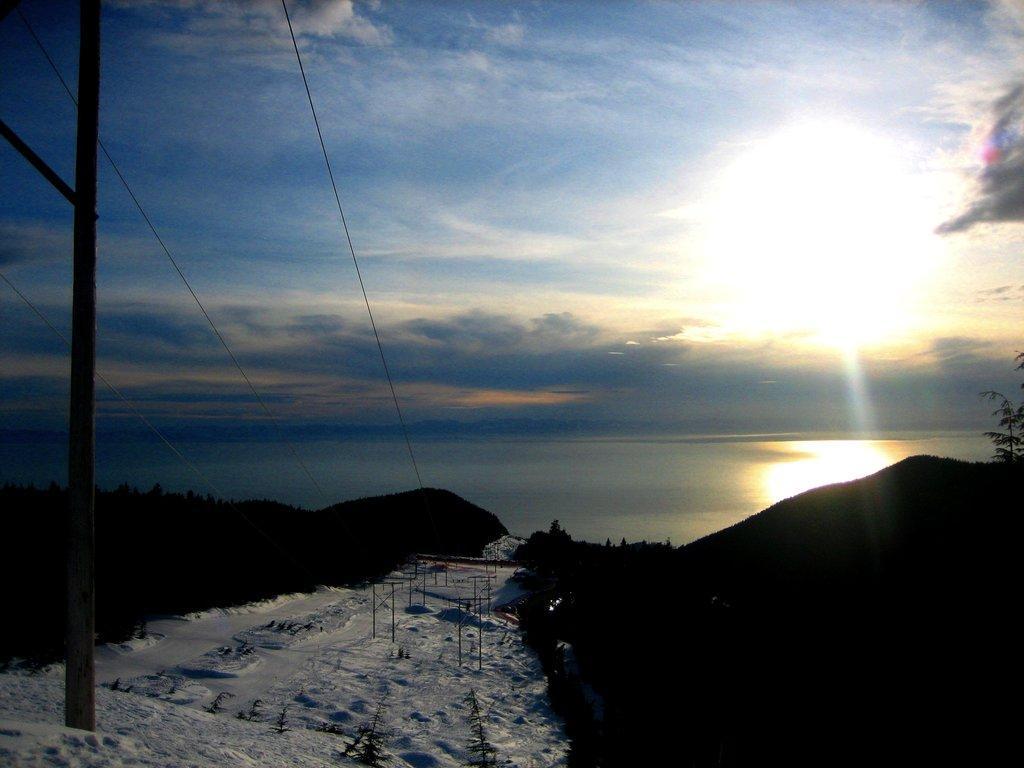In one or two sentences, can you explain what this image depicts? In this picture I can observe some snow on the land. On the left side there is a pole. I can observe some trees. In the background there is a river and a sky with some clouds. On the right side I can observe a sun in the sky. 